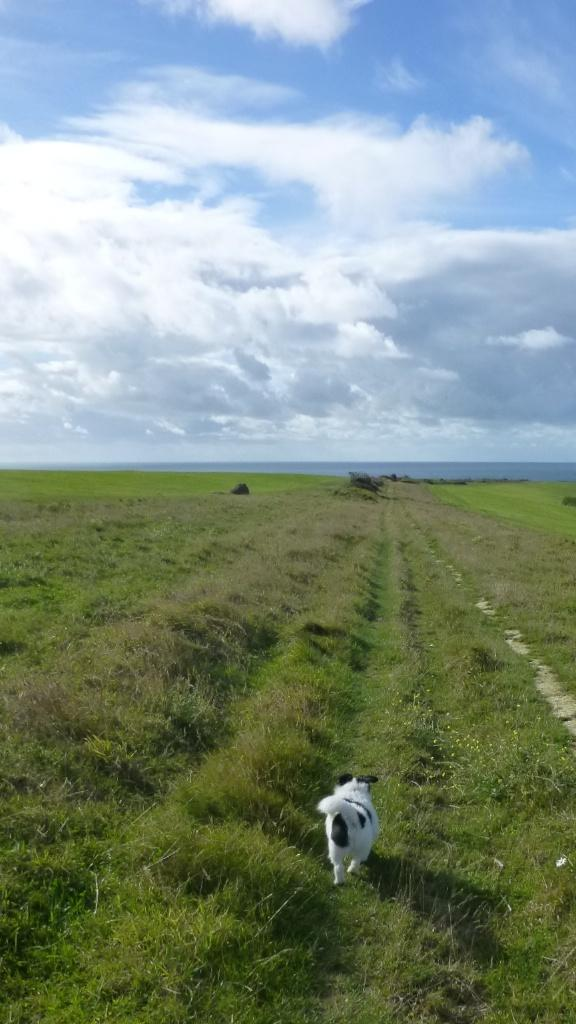What type of surface is visible on the ground in the image? There is grass on the ground in the image. What animal can be seen in the image? There is a dog in the image. What colors does the dog have? The dog is white and black in color. What is the condition of the sky in the image? The sky is blue and cloudy in the image. How does the dog quietly receive approval from the audience in the image? There is no indication in the image that the dog is receiving approval from an audience, nor is there any mention of the dog being quiet. 